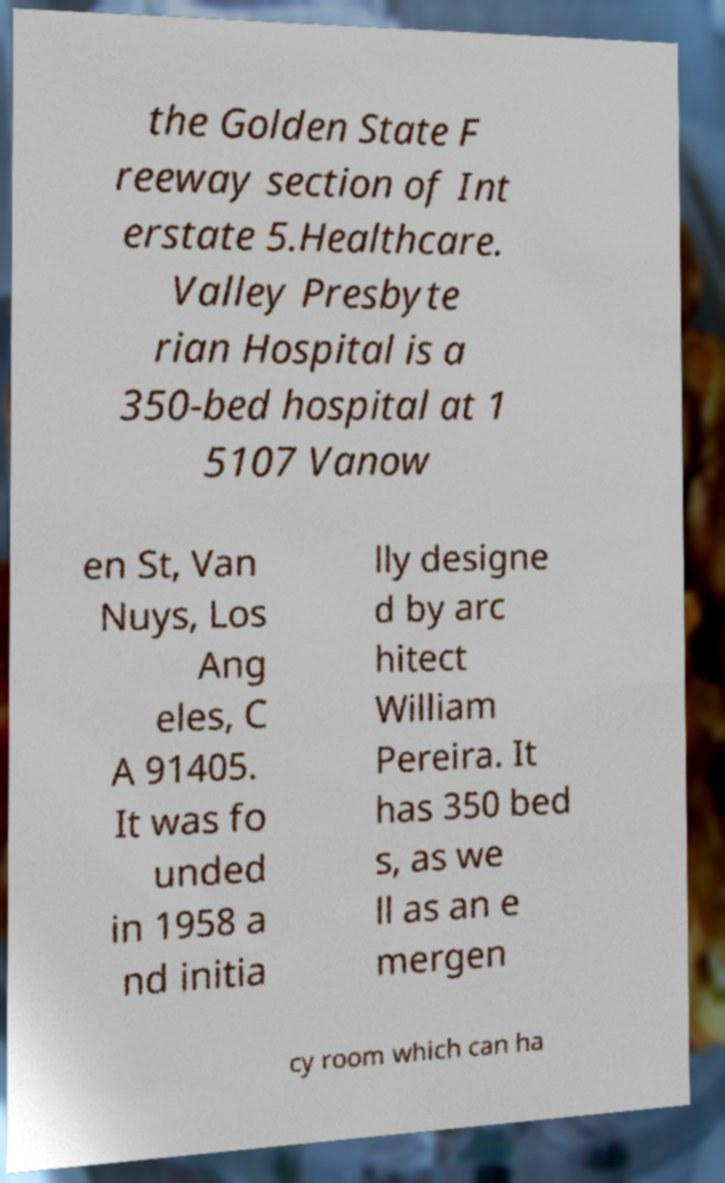I need the written content from this picture converted into text. Can you do that? the Golden State F reeway section of Int erstate 5.Healthcare. Valley Presbyte rian Hospital is a 350-bed hospital at 1 5107 Vanow en St, Van Nuys, Los Ang eles, C A 91405. It was fo unded in 1958 a nd initia lly designe d by arc hitect William Pereira. It has 350 bed s, as we ll as an e mergen cy room which can ha 